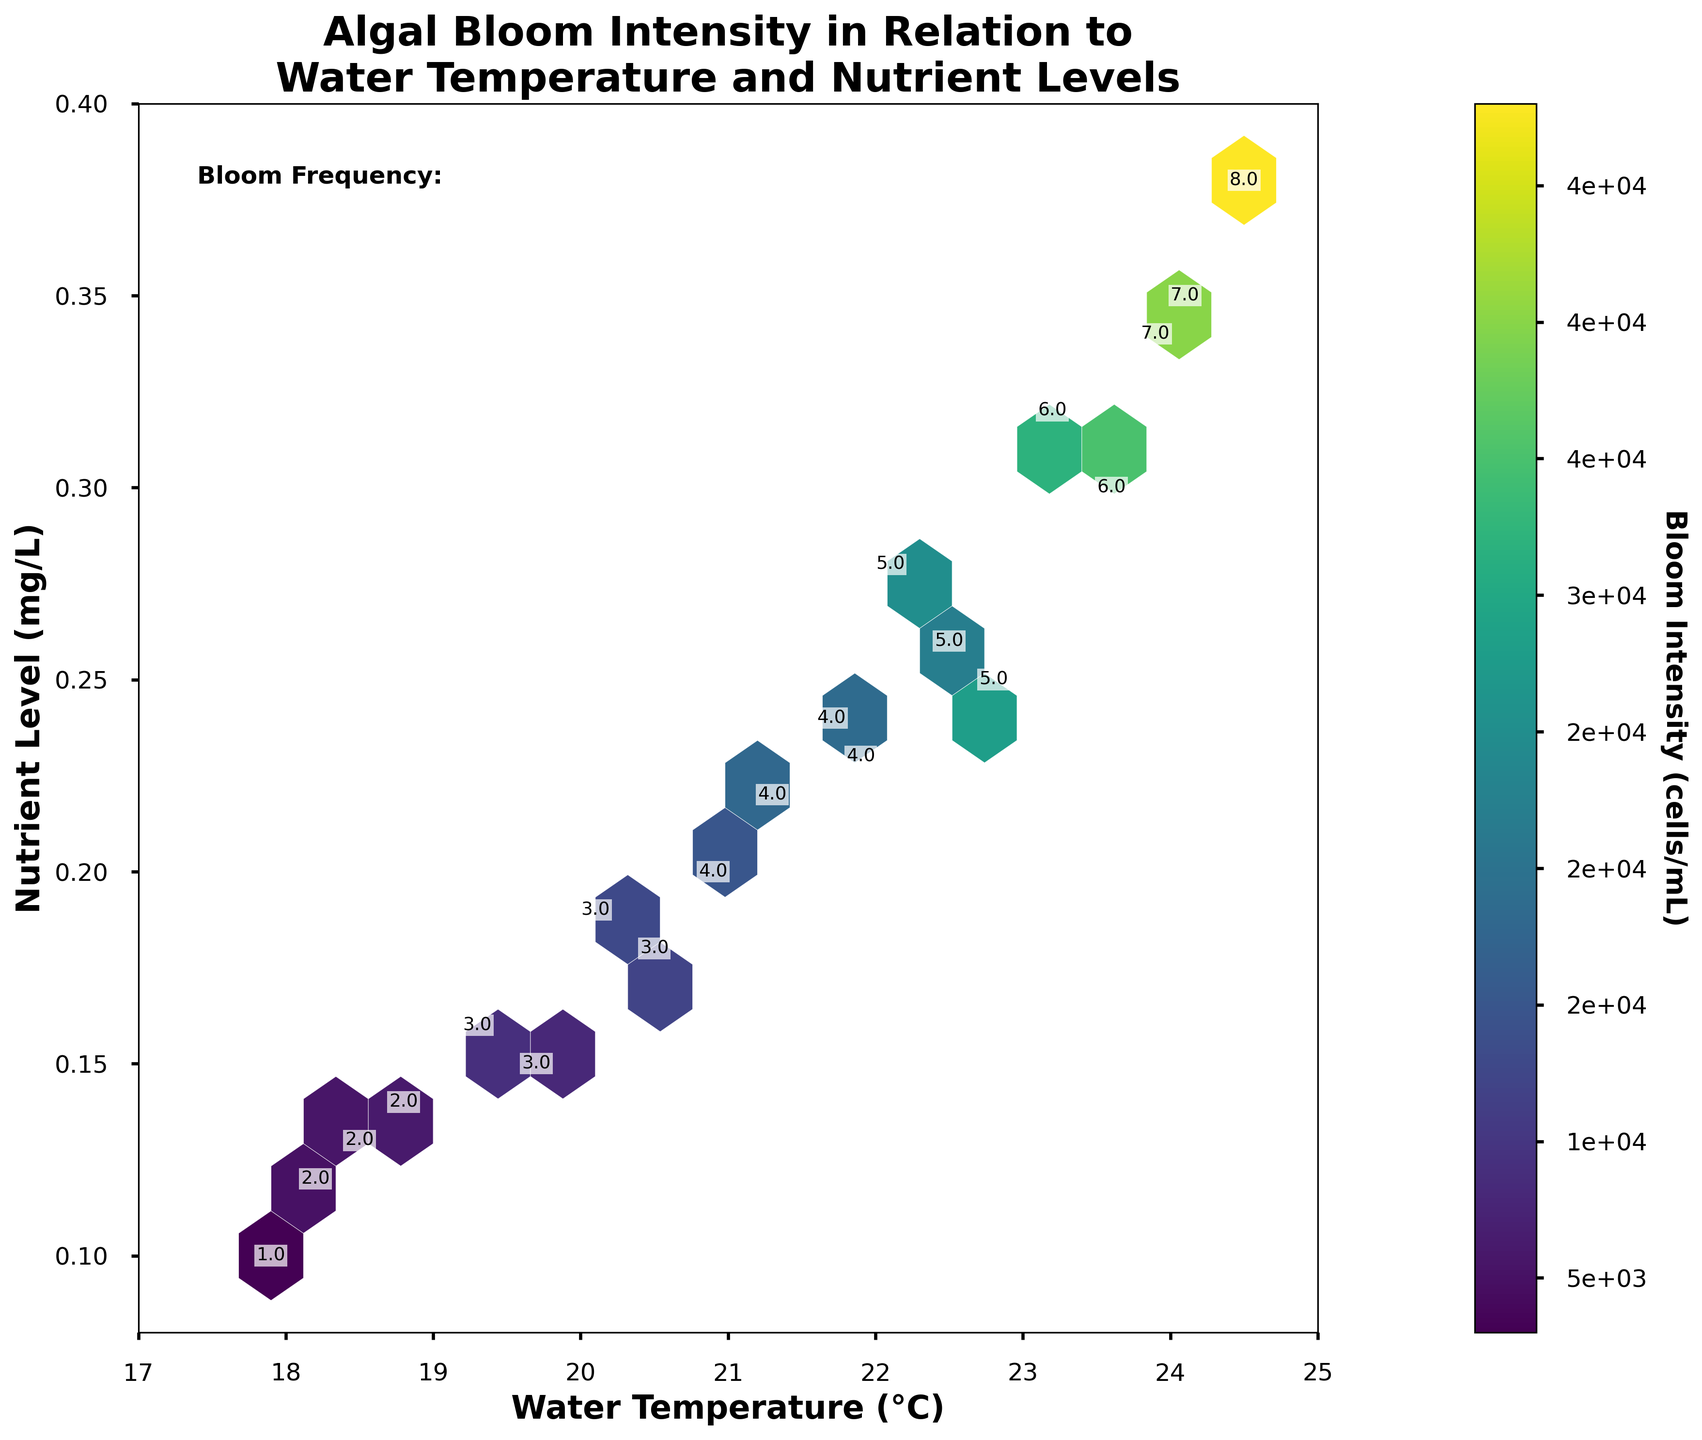What does the title of the hexbin plot indicate about the study? The title of the plot is "Algal Bloom Intensity in Relation to Water Temperature and Nutrient Levels," which indicates that the study is examining how the intensity of algal blooms correlates with different water temperatures and nutrient levels.
Answer: "Algal Bloom Intensity in Relation to Water Temperature and Nutrient Levels" What range of water temperatures is covered in the plot? The x-axis of the plot represents the water temperature with a range marked from 17°C to 25°C.
Answer: 17°C to 25°C What is the hexbin plot's color scheme used to represent? The color scheme in the hexbin plot represents the intensity of algal blooms in cells per mL, where the color bar shows that darker colors correspond to higher intensities.
Answer: Bloom Intensity (cells/mL) How many levels of bloom frequency can you find represented as text within the plot? The additional information in the plot shows varying numbers, indicating bloom frequency. The frequencies range from 1 to 8 per year.
Answer: 1 to 8 Which combination of water temperature and nutrient level shows the highest bloom intensity based on the hexbin color? By checking the color bar and the darkest hexagon within the plot, the highest bloom intensity occurs around a water temperature of 24.5°C and a nutrient level of 0.38 mg/L.
Answer: 24.5°C, 0.38 mg/L Is there a region in the plot where both nutrient levels and water temperatures are low? What is the bloom frequency in this region? The region with both low nutrient levels (around 0.1 mg/L) and low water temperatures (around 18°C) shows a bloom frequency marked as "1" per year based on the text annotations within that hexagon.
Answer: Frequency of 1 per year What is the average bloom intensity for water temperatures above 22°C? The data indicates multiple points above 22°C. To find the average bloom intensity, sum all bloom intensities associated with temperatures above 22°C (28000 + 35000 + 42000 + 25000 + 32000 + 48000 + 22000 + 38000) and divide by the number of data points, which is 8: (28000 + 35000 + 42000 + 25000 + 32000 + 48000 + 22000 + 38000)/8 = 30250.
Answer: 30250 cells/mL Do higher nutrient levels generally correlate with higher bloom frequencies? By examining the text annotations for bloom frequency in conjunction with the nutrient levels on the y-axis, it is observable that higher nutrient levels (above 0.25 mg/L) usually correspond to higher bloom frequencies (5-8 per year).
Answer: Yes Does the plot indicate a specific pattern or trend between bloom intensity and water temperature? The plot indicates that higher water temperatures, especially above 22°C, coincide with higher bloom intensities as represented by darker hexagons in those regions.
Answer: Higher temperatures generally lead to higher bloom intensities Which has a greater effect on bloom intensity according to the plot: nutrient level or water temperature? The trend in the plot shows that both parameters influence bloom intensity but nutrient levels appear more directly correlated with higher intensities (darker hexagons), as extremely high bloom intensities are associated with higher nutrient levels consistently.
Answer: Nutrient level 